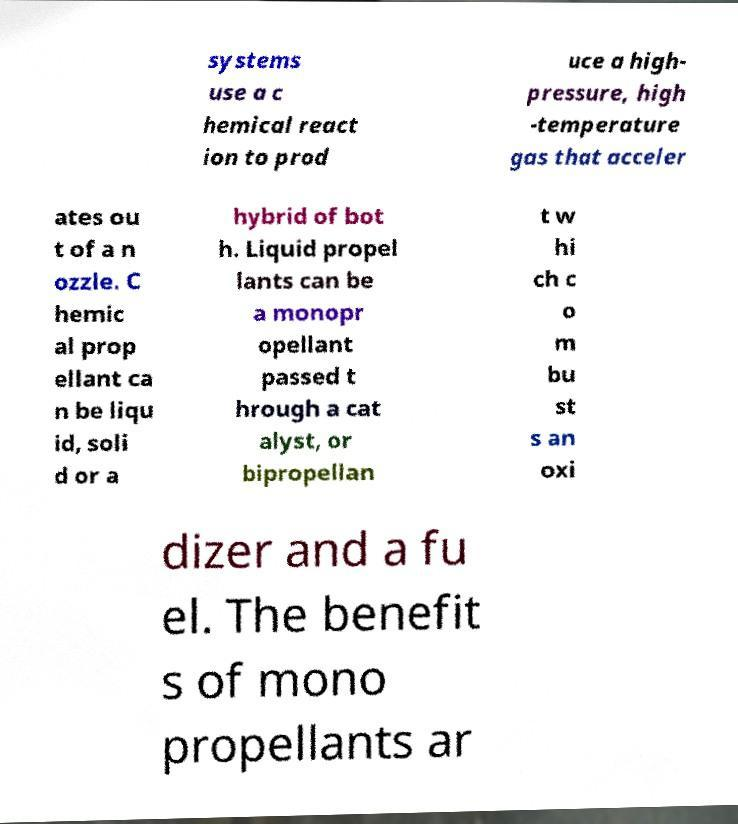Can you read and provide the text displayed in the image?This photo seems to have some interesting text. Can you extract and type it out for me? systems use a c hemical react ion to prod uce a high- pressure, high -temperature gas that acceler ates ou t of a n ozzle. C hemic al prop ellant ca n be liqu id, soli d or a hybrid of bot h. Liquid propel lants can be a monopr opellant passed t hrough a cat alyst, or bipropellan t w hi ch c o m bu st s an oxi dizer and a fu el. The benefit s of mono propellants ar 